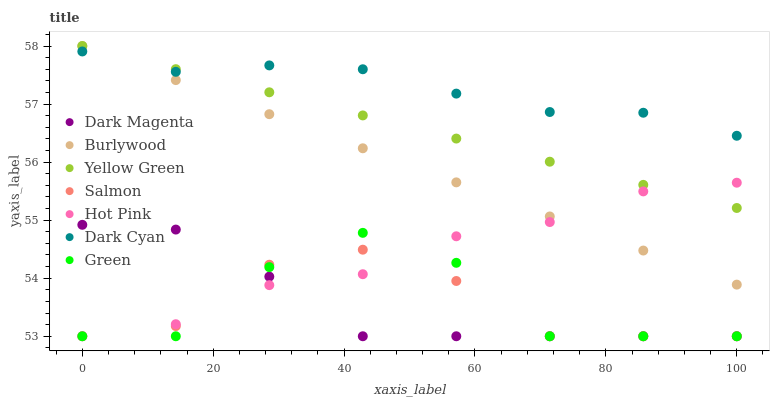Does Dark Magenta have the minimum area under the curve?
Answer yes or no. Yes. Does Dark Cyan have the maximum area under the curve?
Answer yes or no. Yes. Does Burlywood have the minimum area under the curve?
Answer yes or no. No. Does Burlywood have the maximum area under the curve?
Answer yes or no. No. Is Burlywood the smoothest?
Answer yes or no. Yes. Is Green the roughest?
Answer yes or no. Yes. Is Hot Pink the smoothest?
Answer yes or no. No. Is Hot Pink the roughest?
Answer yes or no. No. Does Dark Magenta have the lowest value?
Answer yes or no. Yes. Does Burlywood have the lowest value?
Answer yes or no. No. Does Yellow Green have the highest value?
Answer yes or no. Yes. Does Hot Pink have the highest value?
Answer yes or no. No. Is Dark Magenta less than Burlywood?
Answer yes or no. Yes. Is Dark Cyan greater than Green?
Answer yes or no. Yes. Does Salmon intersect Hot Pink?
Answer yes or no. Yes. Is Salmon less than Hot Pink?
Answer yes or no. No. Is Salmon greater than Hot Pink?
Answer yes or no. No. Does Dark Magenta intersect Burlywood?
Answer yes or no. No. 